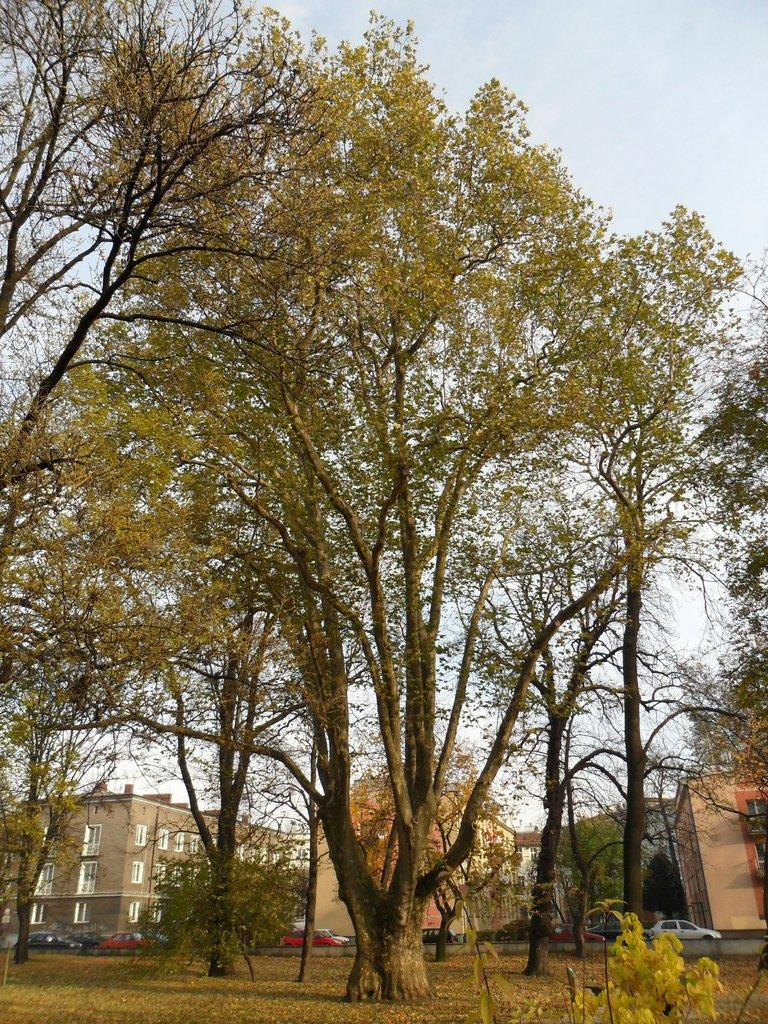What type of structures can be seen in the image? There are buildings in the image. What is happening on the road in the image? Motor vehicles are present on the road in the image. What type of vegetation is visible in the image? There are plants and trees in the image. What is visible in the background of the image? The sky is visible in the background of the image. What can be seen in the sky? Clouds are present in the sky. Can you tell me how many cats are playing with the zephyr in the image? There are no cats or zephyrs present in the image. What type of party is happening in the image? There is no party depicted in the image; it features buildings, motor vehicles, plants, trees, and a sky with clouds. 